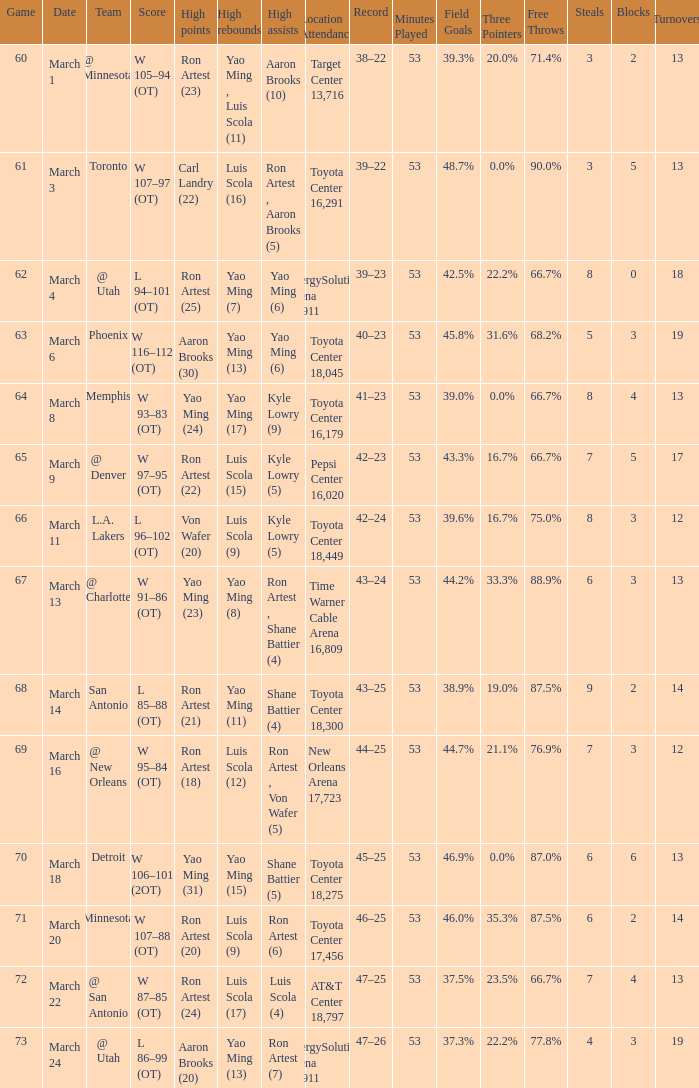Who had the most poinst in game 72? Ron Artest (24). 